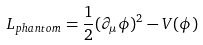Convert formula to latex. <formula><loc_0><loc_0><loc_500><loc_500>L _ { p h a n t o m } = \frac { 1 } { 2 } ( \partial _ { \mu } \phi ) ^ { 2 } - V ( \phi )</formula> 